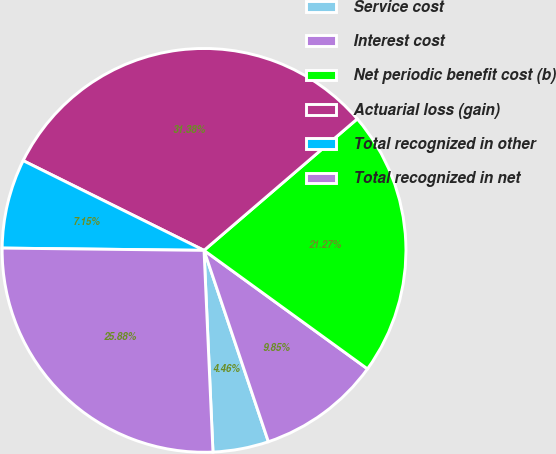Convert chart to OTSL. <chart><loc_0><loc_0><loc_500><loc_500><pie_chart><fcel>Service cost<fcel>Interest cost<fcel>Net periodic benefit cost (b)<fcel>Actuarial loss (gain)<fcel>Total recognized in other<fcel>Total recognized in net<nl><fcel>4.46%<fcel>9.85%<fcel>21.27%<fcel>31.38%<fcel>7.15%<fcel>25.88%<nl></chart> 